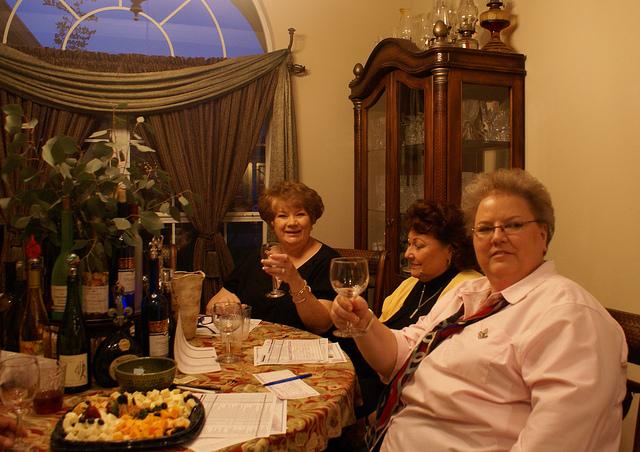Is the woman on the right hungry?
Write a very short answer. No. Is there a plant on the table?
Keep it brief. Yes. What is on top of the China cabinet?
Give a very brief answer. Oil lamps. 